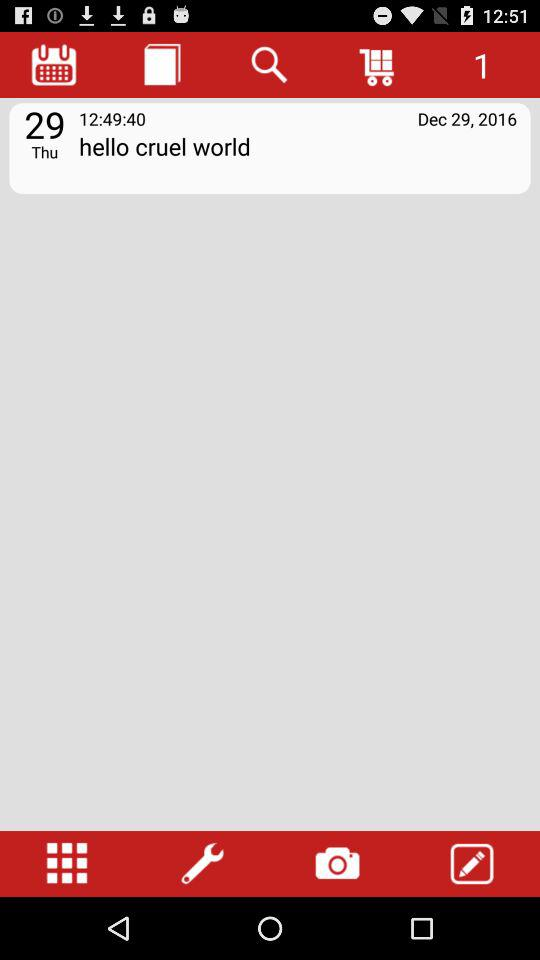On what date was the folder "hello cruel world" created? The folder "hello cruel world" was created on 29th December, 2016. 